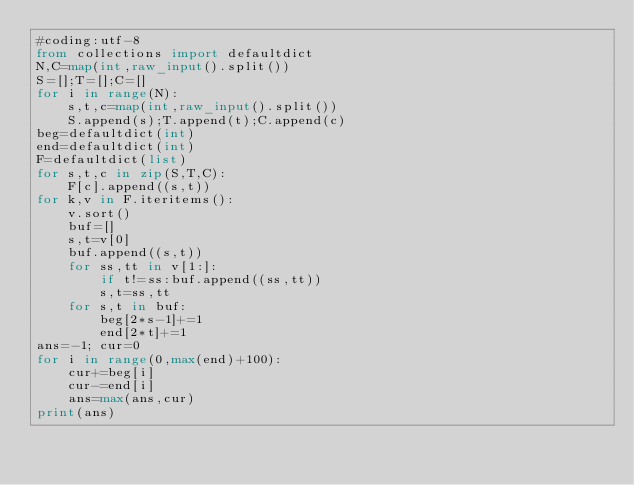Convert code to text. <code><loc_0><loc_0><loc_500><loc_500><_Python_>#coding:utf-8
from collections import defaultdict
N,C=map(int,raw_input().split())
S=[];T=[];C=[]
for i in range(N):
    s,t,c=map(int,raw_input().split())
    S.append(s);T.append(t);C.append(c)
beg=defaultdict(int)
end=defaultdict(int)
F=defaultdict(list)
for s,t,c in zip(S,T,C):
    F[c].append((s,t))
for k,v in F.iteritems():
    v.sort()
    buf=[]
    s,t=v[0]
    buf.append((s,t))
    for ss,tt in v[1:]:
        if t!=ss:buf.append((ss,tt))
        s,t=ss,tt
    for s,t in buf:
        beg[2*s-1]+=1
        end[2*t]+=1
ans=-1; cur=0
for i in range(0,max(end)+100):
    cur+=beg[i]
    cur-=end[i]
    ans=max(ans,cur)
print(ans)
</code> 